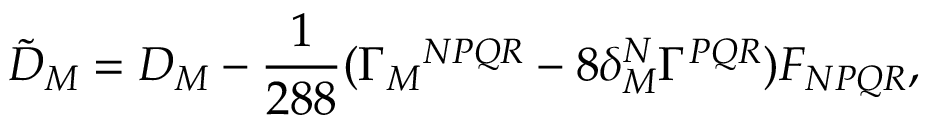Convert formula to latex. <formula><loc_0><loc_0><loc_500><loc_500>{ \tilde { D } } _ { M } = D _ { M } - \frac { 1 } { 2 8 8 } ( \Gamma _ { M ^ { N P Q R } - 8 \delta _ { M } ^ { N } \Gamma ^ { P Q R } ) F _ { N P Q R } ,</formula> 